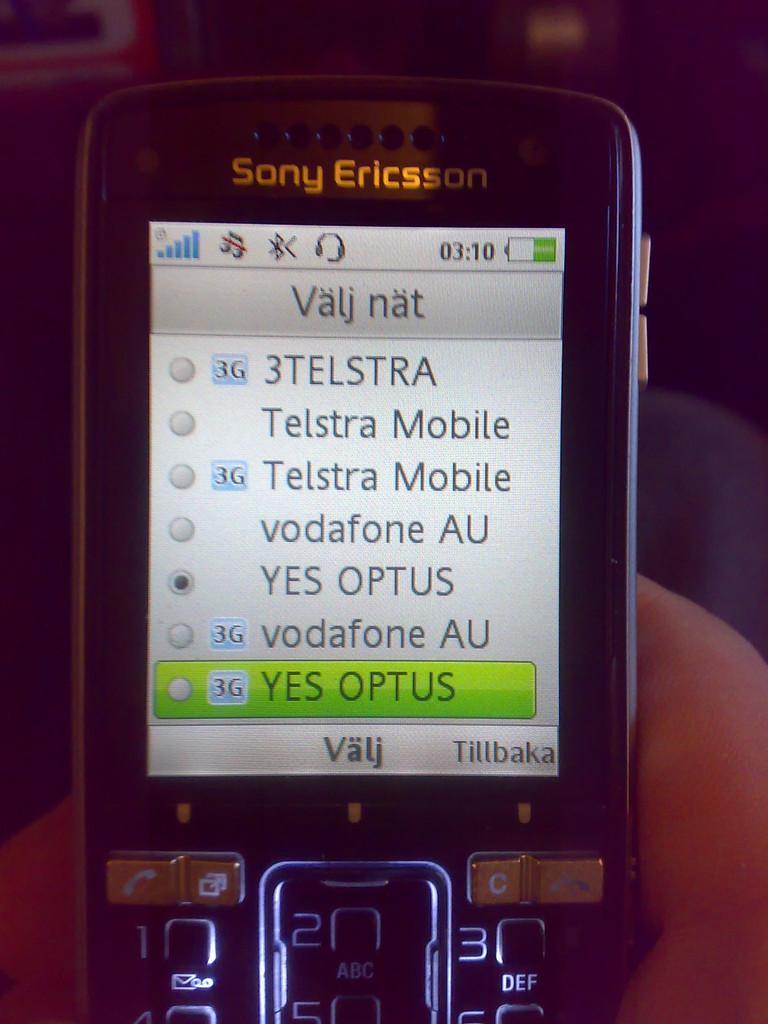<image>
Describe the image concisely. A picture of a Suny Ericsson phone and the word Valj at the bottom. 